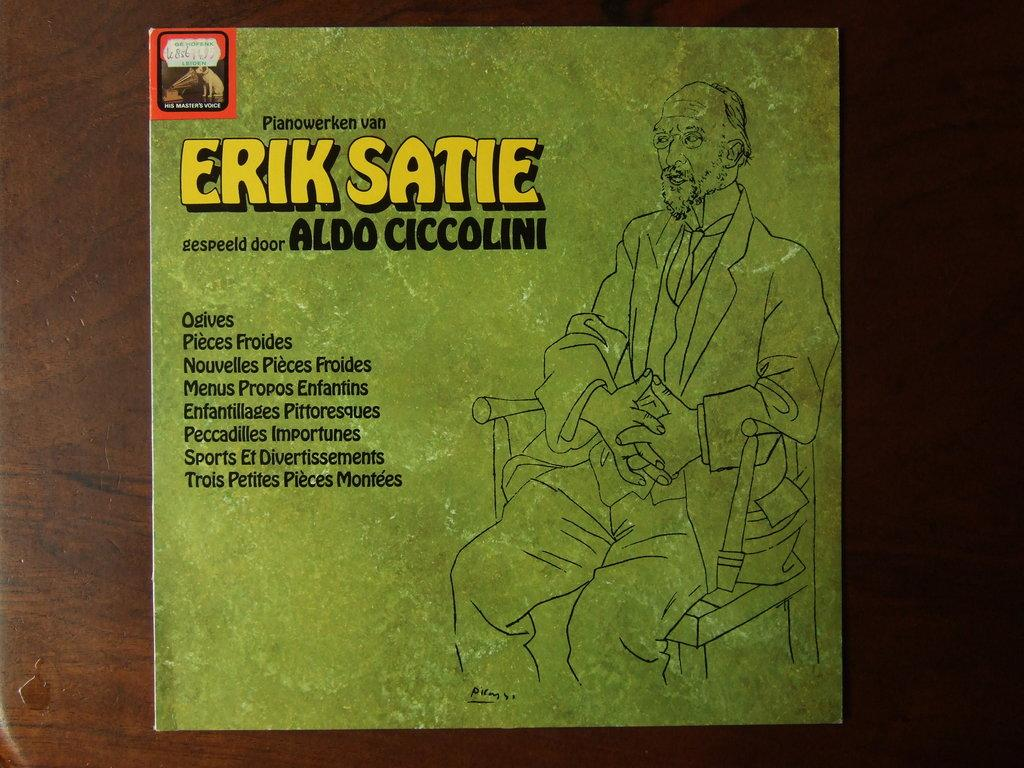<image>
Describe the image concisely. an album of Erik Saties work is green with a man on it 